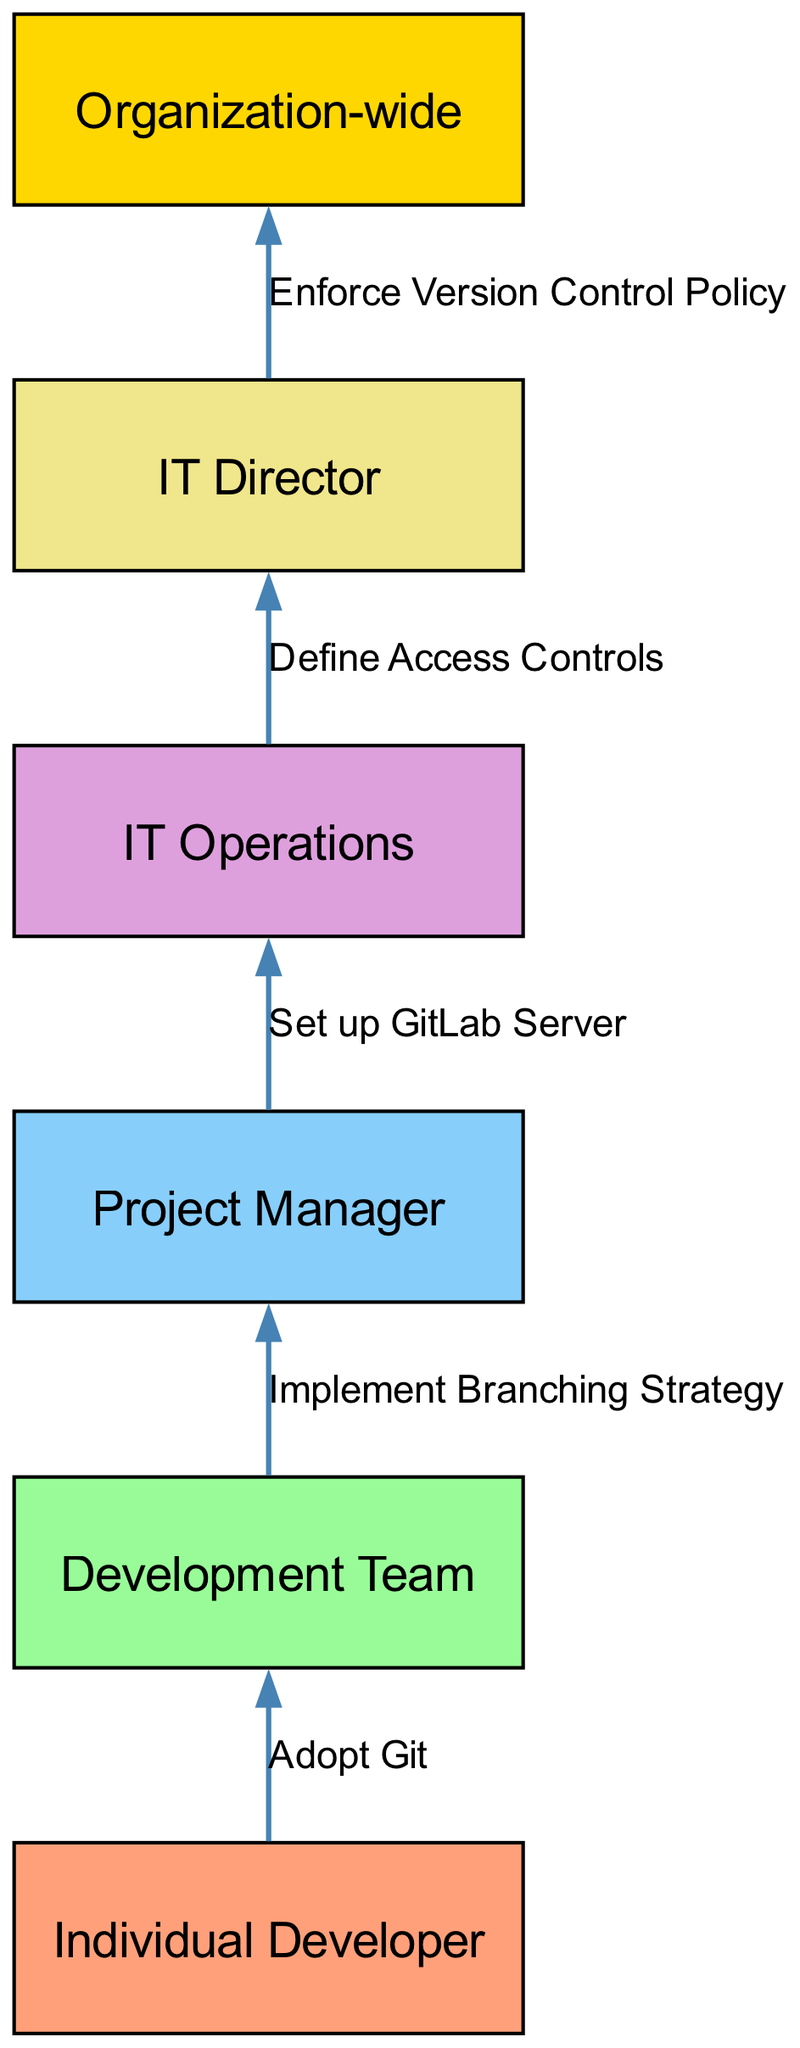What is the first step in the version control adoption process? The first step is where the "Individual Developer" adopts Git. This is indicated as the starting point in the flow, showing that the process begins with individual developers.
Answer: Adopt Git What is the last entity involved in the process? The last entity involved in the process is "Organization-wide," as it is the final node that is reached after the other steps are completed.
Answer: Organization-wide How many nodes are present in the diagram? The diagram features six distinct nodes, which represent the different stages or entities involved in the version control adoption process.
Answer: Six What is the relationship between Development Team and Project Manager? The relationship is that the Development Team implements a branching strategy, which connects these two nodes in the process.
Answer: Implement Branching Strategy What does IT Operations do in this process? IT Operations is responsible for setting up the GitLab Server, as indicated by the connection from Project Manager to IT Operations in the flow.
Answer: Set up GitLab Server Who defines the access controls? The access controls are defined by the IT Director, as shown in the diagram. This is the action that follows the setup of the GitLab Server by IT Operations.
Answer: Define Access Controls What is the direction of flow from the Project Manager to IT Operations? The direction of flow is a direct connection where the Project Manager sets up the GitLab Server, progressing the adoption process from management to operational integration.
Answer: Set up GitLab Server How does the version control policy become organization-wide? The process culminates with the IT Director enforcing the version control policy, which signifies the final step in transitioning to an organization-wide implementation.
Answer: Enforce Version Control Policy 